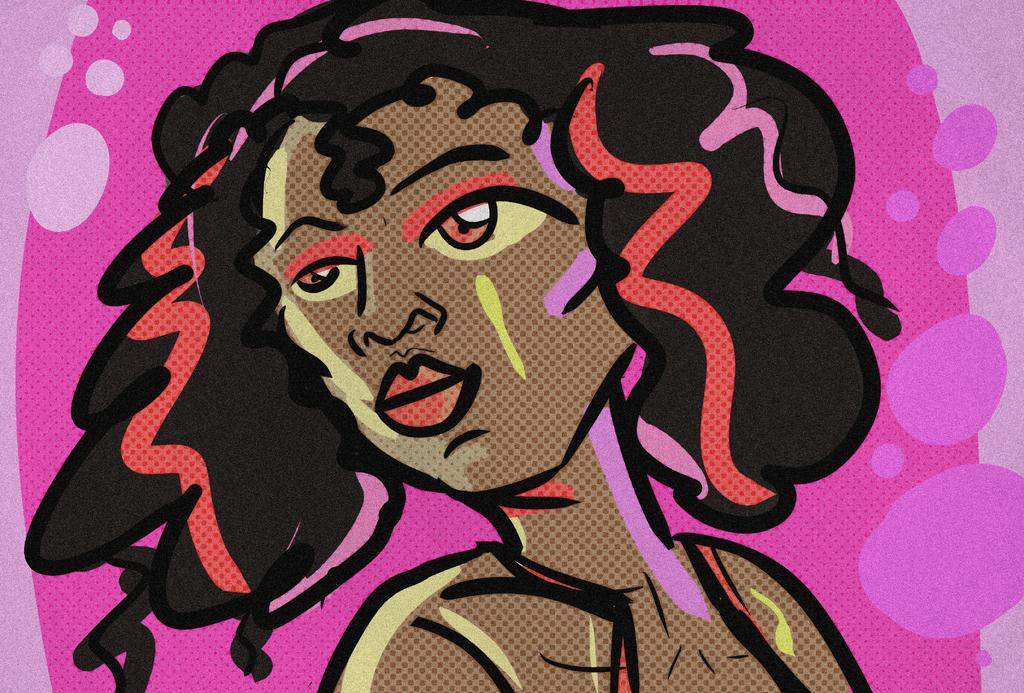What is depicted in the painting in the image? The image contains a painting of a woman. What colors are used in the painting? The painting uses black, brown, red, and pink colors. What is the color of the background in the painting? The background of the painting is pink in color. What type of rake is being used to create the painting in the image? There is no rake present in the image; it is a painting of a woman. How does the range of colors in the painting affect the overall mood of the image? The question cannot be answered definitively, as the mood of the image is subjective and not explicitly mentioned in the provided facts. 